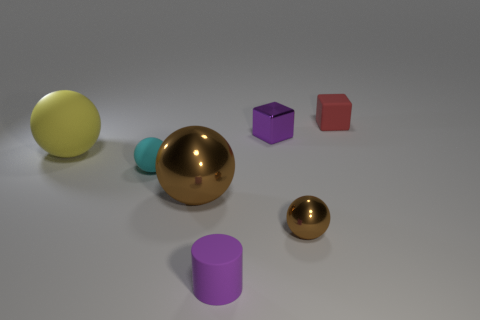Subtract 1 balls. How many balls are left? 3 Add 1 small yellow shiny objects. How many objects exist? 8 Subtract all spheres. How many objects are left? 3 Subtract 0 purple spheres. How many objects are left? 7 Subtract all yellow things. Subtract all tiny purple matte things. How many objects are left? 5 Add 4 small cylinders. How many small cylinders are left? 5 Add 2 tiny cyan balls. How many tiny cyan balls exist? 3 